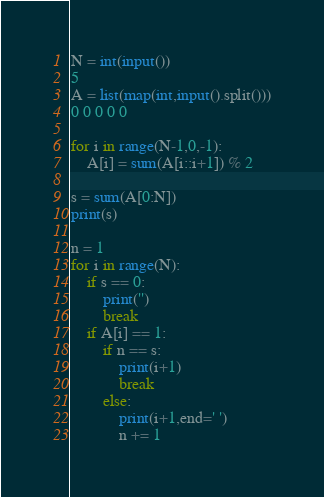<code> <loc_0><loc_0><loc_500><loc_500><_Python_>N = int(input())
5
A = list(map(int,input().split()))
0 0 0 0 0

for i in range(N-1,0,-1):
    A[i] = sum(A[i::i+1]) % 2

s = sum(A[0:N])
print(s)

n = 1
for i in range(N):
    if s == 0:
        print('')
        break
    if A[i] == 1:
        if n == s:
            print(i+1)
            break
        else:
            print(i+1,end=' ')
            n += 1
</code> 